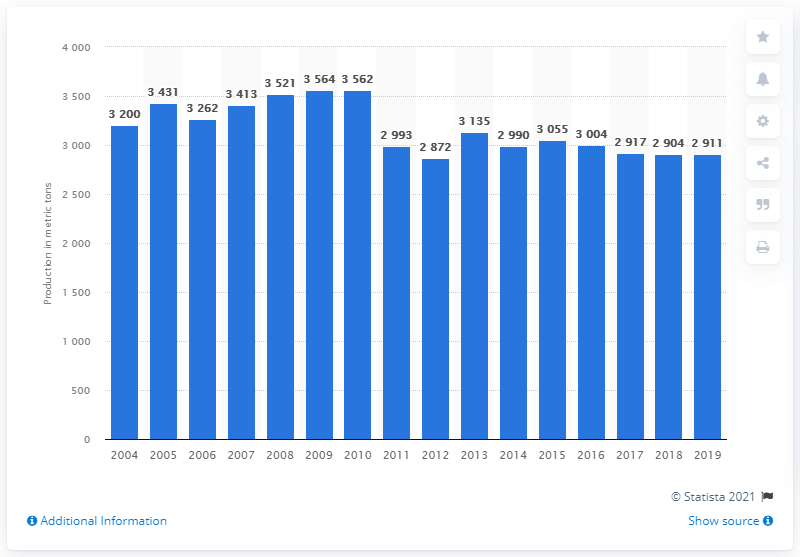Mention a couple of crucial points in this snapshot. In 2019, Russia's uranium mining production was 29,110 metric tons. 